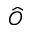Convert formula to latex. <formula><loc_0><loc_0><loc_500><loc_500>\widehat { O }</formula> 